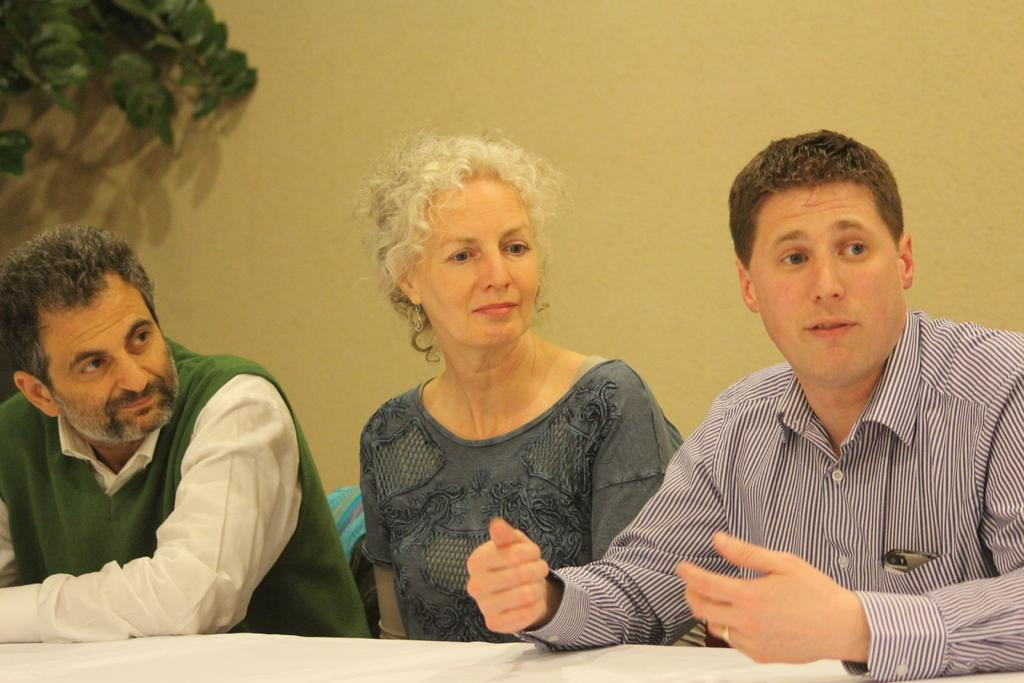What are the people in the image doing? The people in the image are sitting. What is in front of the people? There is a table in front of the people. What can be seen in the background of the image? There is a wall and green leaves visible in the background of the image. What type of curtain can be seen hanging from the seashore in the image? There is no seashore or curtain present in the image. 